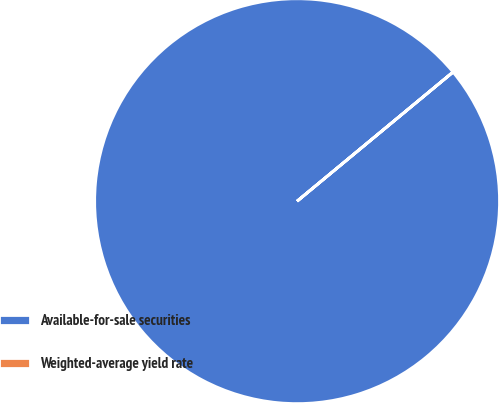Convert chart to OTSL. <chart><loc_0><loc_0><loc_500><loc_500><pie_chart><fcel>Available-for-sale securities<fcel>Weighted-average yield rate<nl><fcel>99.99%<fcel>0.01%<nl></chart> 